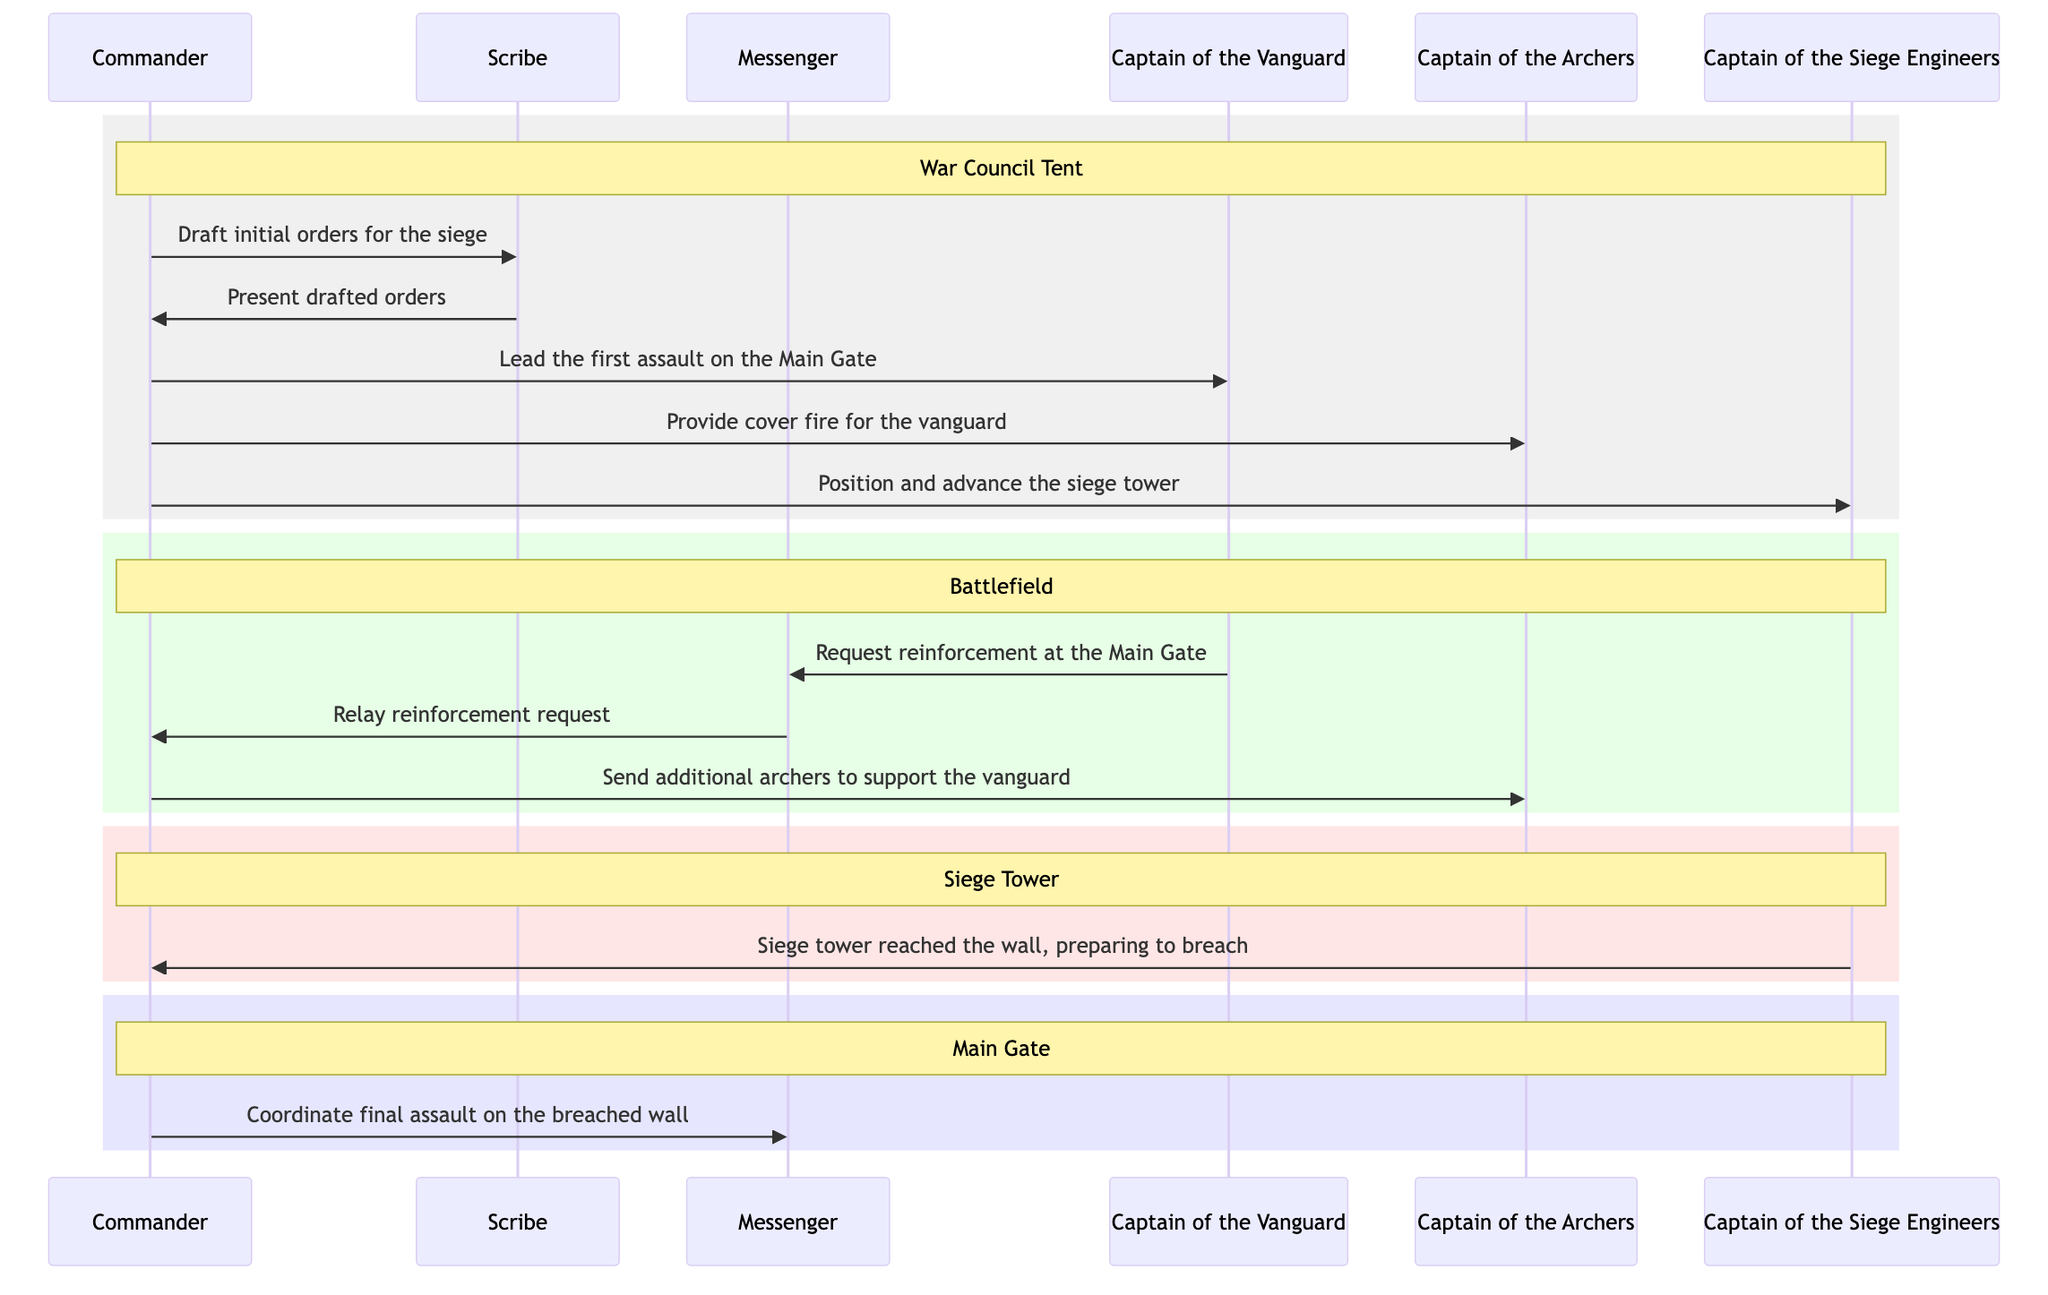What is the first command given by the Commander? The first command given by the Commander to the Scribe is to "Draft initial orders for the siege." The flow of communication starts with the Commander allocating tasks, which initiates the process of siege preparation.
Answer: Draft initial orders for the siege How many key figures are involved in the communication? The diagram shows six key figures involved: Commander, Scribe, Messenger, Captain of the Vanguard, Captain of the Archers, and Captain of the Siege Engineers. Counting each participant in the sequence diagram provides the total.
Answer: 6 What is the message from the Captain of the Vanguard to the Messenger? The Captain of the Vanguard asks the Messenger to "Request reinforcement at the Main Gate." This is identified clearly in the flow from the Vanguard Captain to the Messenger, indicating a critical need for more troops.
Answer: Request reinforcement at the Main Gate In which location does the Siege Engineer report the status of the siege tower? The Siege Engineer reports the status of the siege tower in the "Siege Tower" section of the diagram, where it indicates that the tower has reached the wall and is preparing to breach. This section specifically represents the actions and decisions pertaining to the siege tower.
Answer: Siege Tower Who receives the command to provide cover fire? The command to provide cover fire is given to the Captain of the Archers. The diagram visually represents this communication flow from the Commander directly to the Archers Captain, emphasizing the role of archers in the siege strategy.
Answer: Captain of the Archers What action follows the command to "Draft initial orders for the siege"? The action that follows is the Scribe presenting the drafted orders to the Commander. This shows the immediate response required after a command is given, showing the iterative nature of communication and decision-making.
Answer: Present drafted orders 